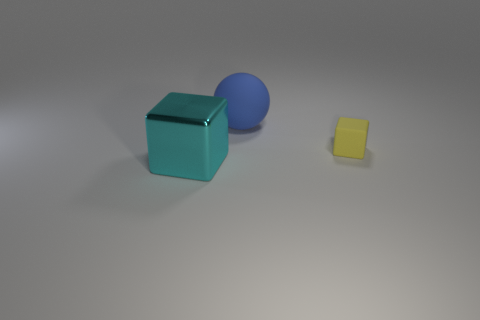Is there anything else that is the same size as the rubber block?
Offer a terse response. No. There is a blue sphere; is it the same size as the matte object that is in front of the blue matte thing?
Keep it short and to the point. No. What shape is the thing that is both in front of the large blue thing and behind the cyan shiny object?
Give a very brief answer. Cube. What number of big things are either blue spheres or cyan blocks?
Make the answer very short. 2. Are there the same number of big shiny things in front of the cyan shiny cube and tiny yellow rubber blocks that are to the right of the blue sphere?
Your response must be concise. No. What number of other objects are the same color as the large shiny thing?
Offer a very short reply. 0. Is the number of matte spheres in front of the large blue thing the same as the number of yellow cubes?
Offer a very short reply. No. Is the size of the cyan shiny object the same as the yellow rubber block?
Give a very brief answer. No. What material is the thing that is both left of the yellow rubber object and in front of the matte sphere?
Provide a short and direct response. Metal. How many other objects are the same shape as the yellow object?
Ensure brevity in your answer.  1. 